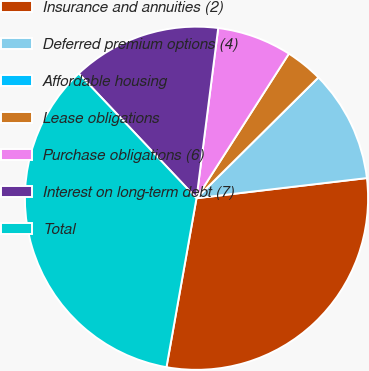Convert chart to OTSL. <chart><loc_0><loc_0><loc_500><loc_500><pie_chart><fcel>Insurance and annuities (2)<fcel>Deferred premium options (4)<fcel>Affordable housing<fcel>Lease obligations<fcel>Purchase obligations (6)<fcel>Interest on long-term debt (7)<fcel>Total<nl><fcel>29.67%<fcel>10.55%<fcel>0.0%<fcel>3.52%<fcel>7.03%<fcel>14.06%<fcel>35.15%<nl></chart> 